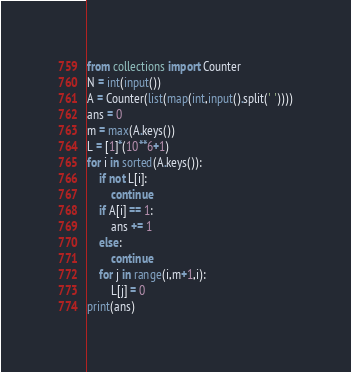<code> <loc_0><loc_0><loc_500><loc_500><_Python_>from collections import Counter
N = int(input())
A = Counter(list(map(int,input().split(' '))))
ans = 0
m = max(A.keys())
L = [1]*(10**6+1)
for i in sorted(A.keys()):
    if not L[i]:
        continue
    if A[i] == 1:
        ans += 1
    else:
        continue
    for j in range(i,m+1,i):
        L[j] = 0
print(ans)</code> 